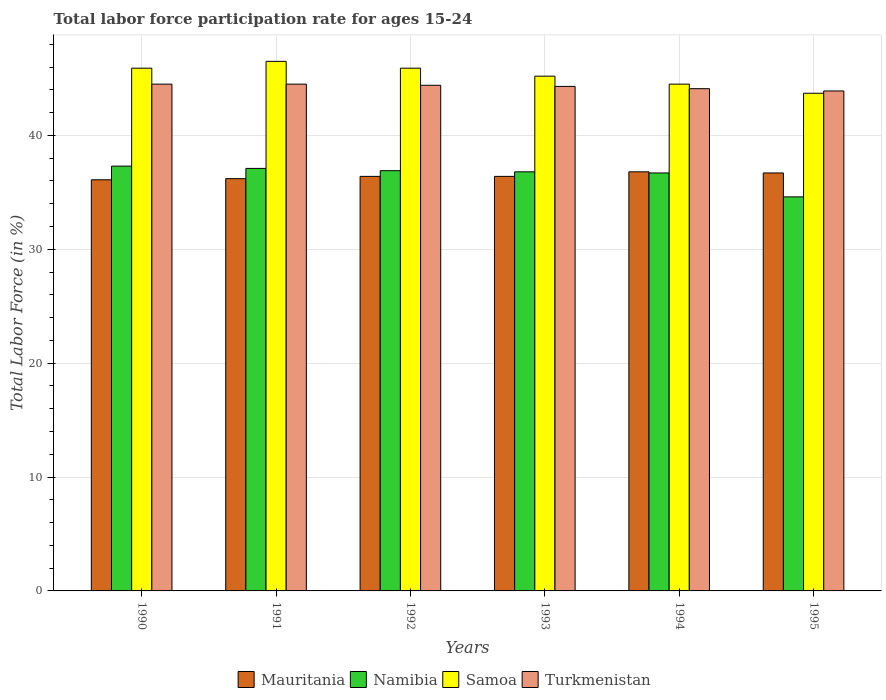How many different coloured bars are there?
Ensure brevity in your answer.  4. Are the number of bars per tick equal to the number of legend labels?
Offer a terse response. Yes. Are the number of bars on each tick of the X-axis equal?
Offer a very short reply. Yes. How many bars are there on the 5th tick from the left?
Keep it short and to the point. 4. What is the label of the 3rd group of bars from the left?
Your response must be concise. 1992. What is the labor force participation rate in Turkmenistan in 1991?
Provide a short and direct response. 44.5. Across all years, what is the maximum labor force participation rate in Samoa?
Your answer should be very brief. 46.5. Across all years, what is the minimum labor force participation rate in Turkmenistan?
Your answer should be compact. 43.9. In which year was the labor force participation rate in Namibia maximum?
Offer a very short reply. 1990. What is the total labor force participation rate in Namibia in the graph?
Ensure brevity in your answer.  219.4. What is the difference between the labor force participation rate in Namibia in 1991 and that in 1992?
Provide a succinct answer. 0.2. What is the difference between the labor force participation rate in Mauritania in 1992 and the labor force participation rate in Samoa in 1995?
Ensure brevity in your answer.  -7.3. What is the average labor force participation rate in Mauritania per year?
Give a very brief answer. 36.43. What is the ratio of the labor force participation rate in Namibia in 1991 to that in 1993?
Ensure brevity in your answer.  1.01. What is the difference between the highest and the second highest labor force participation rate in Samoa?
Provide a succinct answer. 0.6. What is the difference between the highest and the lowest labor force participation rate in Turkmenistan?
Provide a short and direct response. 0.6. Is it the case that in every year, the sum of the labor force participation rate in Samoa and labor force participation rate in Turkmenistan is greater than the sum of labor force participation rate in Mauritania and labor force participation rate in Namibia?
Offer a terse response. Yes. What does the 4th bar from the left in 1995 represents?
Your answer should be compact. Turkmenistan. What does the 4th bar from the right in 1994 represents?
Ensure brevity in your answer.  Mauritania. Are all the bars in the graph horizontal?
Ensure brevity in your answer.  No. Where does the legend appear in the graph?
Make the answer very short. Bottom center. What is the title of the graph?
Your response must be concise. Total labor force participation rate for ages 15-24. What is the label or title of the X-axis?
Offer a very short reply. Years. What is the label or title of the Y-axis?
Offer a very short reply. Total Labor Force (in %). What is the Total Labor Force (in %) in Mauritania in 1990?
Offer a very short reply. 36.1. What is the Total Labor Force (in %) of Namibia in 1990?
Keep it short and to the point. 37.3. What is the Total Labor Force (in %) of Samoa in 1990?
Your response must be concise. 45.9. What is the Total Labor Force (in %) in Turkmenistan in 1990?
Give a very brief answer. 44.5. What is the Total Labor Force (in %) of Mauritania in 1991?
Offer a terse response. 36.2. What is the Total Labor Force (in %) in Namibia in 1991?
Offer a very short reply. 37.1. What is the Total Labor Force (in %) of Samoa in 1991?
Ensure brevity in your answer.  46.5. What is the Total Labor Force (in %) in Turkmenistan in 1991?
Provide a succinct answer. 44.5. What is the Total Labor Force (in %) in Mauritania in 1992?
Your answer should be compact. 36.4. What is the Total Labor Force (in %) of Namibia in 1992?
Make the answer very short. 36.9. What is the Total Labor Force (in %) of Samoa in 1992?
Your response must be concise. 45.9. What is the Total Labor Force (in %) of Turkmenistan in 1992?
Offer a very short reply. 44.4. What is the Total Labor Force (in %) in Mauritania in 1993?
Offer a terse response. 36.4. What is the Total Labor Force (in %) of Namibia in 1993?
Provide a short and direct response. 36.8. What is the Total Labor Force (in %) in Samoa in 1993?
Offer a very short reply. 45.2. What is the Total Labor Force (in %) of Turkmenistan in 1993?
Provide a short and direct response. 44.3. What is the Total Labor Force (in %) of Mauritania in 1994?
Keep it short and to the point. 36.8. What is the Total Labor Force (in %) of Namibia in 1994?
Offer a terse response. 36.7. What is the Total Labor Force (in %) in Samoa in 1994?
Your answer should be compact. 44.5. What is the Total Labor Force (in %) of Turkmenistan in 1994?
Your response must be concise. 44.1. What is the Total Labor Force (in %) of Mauritania in 1995?
Offer a very short reply. 36.7. What is the Total Labor Force (in %) in Namibia in 1995?
Ensure brevity in your answer.  34.6. What is the Total Labor Force (in %) in Samoa in 1995?
Your answer should be very brief. 43.7. What is the Total Labor Force (in %) in Turkmenistan in 1995?
Offer a terse response. 43.9. Across all years, what is the maximum Total Labor Force (in %) of Mauritania?
Provide a succinct answer. 36.8. Across all years, what is the maximum Total Labor Force (in %) of Namibia?
Your answer should be very brief. 37.3. Across all years, what is the maximum Total Labor Force (in %) in Samoa?
Your answer should be very brief. 46.5. Across all years, what is the maximum Total Labor Force (in %) of Turkmenistan?
Your answer should be compact. 44.5. Across all years, what is the minimum Total Labor Force (in %) in Mauritania?
Keep it short and to the point. 36.1. Across all years, what is the minimum Total Labor Force (in %) of Namibia?
Your answer should be compact. 34.6. Across all years, what is the minimum Total Labor Force (in %) of Samoa?
Your answer should be very brief. 43.7. Across all years, what is the minimum Total Labor Force (in %) in Turkmenistan?
Provide a short and direct response. 43.9. What is the total Total Labor Force (in %) in Mauritania in the graph?
Keep it short and to the point. 218.6. What is the total Total Labor Force (in %) in Namibia in the graph?
Offer a terse response. 219.4. What is the total Total Labor Force (in %) of Samoa in the graph?
Your answer should be compact. 271.7. What is the total Total Labor Force (in %) in Turkmenistan in the graph?
Provide a short and direct response. 265.7. What is the difference between the Total Labor Force (in %) of Namibia in 1990 and that in 1991?
Offer a very short reply. 0.2. What is the difference between the Total Labor Force (in %) of Samoa in 1990 and that in 1992?
Make the answer very short. 0. What is the difference between the Total Labor Force (in %) in Mauritania in 1990 and that in 1993?
Keep it short and to the point. -0.3. What is the difference between the Total Labor Force (in %) of Samoa in 1990 and that in 1993?
Your answer should be very brief. 0.7. What is the difference between the Total Labor Force (in %) of Turkmenistan in 1990 and that in 1993?
Ensure brevity in your answer.  0.2. What is the difference between the Total Labor Force (in %) in Namibia in 1990 and that in 1994?
Give a very brief answer. 0.6. What is the difference between the Total Labor Force (in %) of Turkmenistan in 1990 and that in 1994?
Offer a very short reply. 0.4. What is the difference between the Total Labor Force (in %) in Turkmenistan in 1990 and that in 1995?
Provide a succinct answer. 0.6. What is the difference between the Total Labor Force (in %) of Mauritania in 1991 and that in 1992?
Make the answer very short. -0.2. What is the difference between the Total Labor Force (in %) of Namibia in 1991 and that in 1992?
Provide a short and direct response. 0.2. What is the difference between the Total Labor Force (in %) of Samoa in 1991 and that in 1992?
Offer a very short reply. 0.6. What is the difference between the Total Labor Force (in %) of Turkmenistan in 1991 and that in 1992?
Give a very brief answer. 0.1. What is the difference between the Total Labor Force (in %) of Namibia in 1991 and that in 1993?
Offer a very short reply. 0.3. What is the difference between the Total Labor Force (in %) of Samoa in 1991 and that in 1993?
Ensure brevity in your answer.  1.3. What is the difference between the Total Labor Force (in %) in Mauritania in 1991 and that in 1994?
Provide a succinct answer. -0.6. What is the difference between the Total Labor Force (in %) of Namibia in 1991 and that in 1994?
Your response must be concise. 0.4. What is the difference between the Total Labor Force (in %) of Samoa in 1991 and that in 1994?
Make the answer very short. 2. What is the difference between the Total Labor Force (in %) in Mauritania in 1991 and that in 1995?
Your answer should be compact. -0.5. What is the difference between the Total Labor Force (in %) of Turkmenistan in 1991 and that in 1995?
Provide a succinct answer. 0.6. What is the difference between the Total Labor Force (in %) of Mauritania in 1992 and that in 1993?
Your answer should be very brief. 0. What is the difference between the Total Labor Force (in %) in Namibia in 1992 and that in 1994?
Your response must be concise. 0.2. What is the difference between the Total Labor Force (in %) in Samoa in 1992 and that in 1994?
Make the answer very short. 1.4. What is the difference between the Total Labor Force (in %) in Turkmenistan in 1992 and that in 1994?
Your response must be concise. 0.3. What is the difference between the Total Labor Force (in %) in Mauritania in 1992 and that in 1995?
Make the answer very short. -0.3. What is the difference between the Total Labor Force (in %) in Turkmenistan in 1992 and that in 1995?
Offer a terse response. 0.5. What is the difference between the Total Labor Force (in %) of Namibia in 1993 and that in 1994?
Ensure brevity in your answer.  0.1. What is the difference between the Total Labor Force (in %) of Turkmenistan in 1993 and that in 1994?
Ensure brevity in your answer.  0.2. What is the difference between the Total Labor Force (in %) of Mauritania in 1993 and that in 1995?
Ensure brevity in your answer.  -0.3. What is the difference between the Total Labor Force (in %) in Samoa in 1993 and that in 1995?
Offer a terse response. 1.5. What is the difference between the Total Labor Force (in %) of Samoa in 1994 and that in 1995?
Ensure brevity in your answer.  0.8. What is the difference between the Total Labor Force (in %) of Turkmenistan in 1994 and that in 1995?
Ensure brevity in your answer.  0.2. What is the difference between the Total Labor Force (in %) in Mauritania in 1990 and the Total Labor Force (in %) in Turkmenistan in 1991?
Provide a short and direct response. -8.4. What is the difference between the Total Labor Force (in %) in Mauritania in 1990 and the Total Labor Force (in %) in Namibia in 1992?
Make the answer very short. -0.8. What is the difference between the Total Labor Force (in %) in Mauritania in 1990 and the Total Labor Force (in %) in Samoa in 1992?
Provide a succinct answer. -9.8. What is the difference between the Total Labor Force (in %) in Mauritania in 1990 and the Total Labor Force (in %) in Turkmenistan in 1992?
Provide a succinct answer. -8.3. What is the difference between the Total Labor Force (in %) in Namibia in 1990 and the Total Labor Force (in %) in Samoa in 1992?
Offer a terse response. -8.6. What is the difference between the Total Labor Force (in %) in Samoa in 1990 and the Total Labor Force (in %) in Turkmenistan in 1992?
Offer a terse response. 1.5. What is the difference between the Total Labor Force (in %) of Mauritania in 1990 and the Total Labor Force (in %) of Namibia in 1993?
Provide a succinct answer. -0.7. What is the difference between the Total Labor Force (in %) of Mauritania in 1990 and the Total Labor Force (in %) of Samoa in 1993?
Provide a succinct answer. -9.1. What is the difference between the Total Labor Force (in %) in Namibia in 1990 and the Total Labor Force (in %) in Samoa in 1993?
Your answer should be very brief. -7.9. What is the difference between the Total Labor Force (in %) in Samoa in 1990 and the Total Labor Force (in %) in Turkmenistan in 1993?
Provide a short and direct response. 1.6. What is the difference between the Total Labor Force (in %) of Mauritania in 1990 and the Total Labor Force (in %) of Namibia in 1994?
Give a very brief answer. -0.6. What is the difference between the Total Labor Force (in %) of Namibia in 1990 and the Total Labor Force (in %) of Samoa in 1994?
Your answer should be very brief. -7.2. What is the difference between the Total Labor Force (in %) of Namibia in 1990 and the Total Labor Force (in %) of Turkmenistan in 1994?
Give a very brief answer. -6.8. What is the difference between the Total Labor Force (in %) in Mauritania in 1990 and the Total Labor Force (in %) in Namibia in 1995?
Your answer should be very brief. 1.5. What is the difference between the Total Labor Force (in %) in Namibia in 1990 and the Total Labor Force (in %) in Samoa in 1995?
Provide a short and direct response. -6.4. What is the difference between the Total Labor Force (in %) in Samoa in 1990 and the Total Labor Force (in %) in Turkmenistan in 1995?
Your answer should be compact. 2. What is the difference between the Total Labor Force (in %) of Mauritania in 1991 and the Total Labor Force (in %) of Namibia in 1992?
Provide a short and direct response. -0.7. What is the difference between the Total Labor Force (in %) of Mauritania in 1991 and the Total Labor Force (in %) of Turkmenistan in 1992?
Provide a short and direct response. -8.2. What is the difference between the Total Labor Force (in %) in Namibia in 1991 and the Total Labor Force (in %) in Turkmenistan in 1992?
Provide a short and direct response. -7.3. What is the difference between the Total Labor Force (in %) in Mauritania in 1991 and the Total Labor Force (in %) in Samoa in 1993?
Your answer should be compact. -9. What is the difference between the Total Labor Force (in %) of Namibia in 1991 and the Total Labor Force (in %) of Samoa in 1994?
Your response must be concise. -7.4. What is the difference between the Total Labor Force (in %) in Namibia in 1991 and the Total Labor Force (in %) in Turkmenistan in 1994?
Keep it short and to the point. -7. What is the difference between the Total Labor Force (in %) of Mauritania in 1991 and the Total Labor Force (in %) of Samoa in 1995?
Give a very brief answer. -7.5. What is the difference between the Total Labor Force (in %) in Namibia in 1991 and the Total Labor Force (in %) in Samoa in 1995?
Your answer should be compact. -6.6. What is the difference between the Total Labor Force (in %) in Samoa in 1991 and the Total Labor Force (in %) in Turkmenistan in 1995?
Provide a short and direct response. 2.6. What is the difference between the Total Labor Force (in %) in Mauritania in 1992 and the Total Labor Force (in %) in Namibia in 1993?
Provide a succinct answer. -0.4. What is the difference between the Total Labor Force (in %) in Mauritania in 1992 and the Total Labor Force (in %) in Samoa in 1993?
Your response must be concise. -8.8. What is the difference between the Total Labor Force (in %) of Mauritania in 1992 and the Total Labor Force (in %) of Turkmenistan in 1993?
Offer a very short reply. -7.9. What is the difference between the Total Labor Force (in %) in Namibia in 1992 and the Total Labor Force (in %) in Turkmenistan in 1993?
Offer a terse response. -7.4. What is the difference between the Total Labor Force (in %) in Samoa in 1992 and the Total Labor Force (in %) in Turkmenistan in 1993?
Provide a short and direct response. 1.6. What is the difference between the Total Labor Force (in %) in Mauritania in 1992 and the Total Labor Force (in %) in Namibia in 1994?
Keep it short and to the point. -0.3. What is the difference between the Total Labor Force (in %) in Mauritania in 1992 and the Total Labor Force (in %) in Samoa in 1994?
Provide a succinct answer. -8.1. What is the difference between the Total Labor Force (in %) in Namibia in 1992 and the Total Labor Force (in %) in Turkmenistan in 1994?
Your response must be concise. -7.2. What is the difference between the Total Labor Force (in %) of Mauritania in 1992 and the Total Labor Force (in %) of Namibia in 1995?
Keep it short and to the point. 1.8. What is the difference between the Total Labor Force (in %) in Mauritania in 1992 and the Total Labor Force (in %) in Turkmenistan in 1995?
Offer a terse response. -7.5. What is the difference between the Total Labor Force (in %) of Namibia in 1992 and the Total Labor Force (in %) of Turkmenistan in 1995?
Offer a terse response. -7. What is the difference between the Total Labor Force (in %) of Samoa in 1992 and the Total Labor Force (in %) of Turkmenistan in 1995?
Keep it short and to the point. 2. What is the difference between the Total Labor Force (in %) in Mauritania in 1993 and the Total Labor Force (in %) in Namibia in 1994?
Keep it short and to the point. -0.3. What is the difference between the Total Labor Force (in %) of Namibia in 1993 and the Total Labor Force (in %) of Turkmenistan in 1994?
Your answer should be very brief. -7.3. What is the difference between the Total Labor Force (in %) of Samoa in 1993 and the Total Labor Force (in %) of Turkmenistan in 1994?
Offer a very short reply. 1.1. What is the difference between the Total Labor Force (in %) in Mauritania in 1993 and the Total Labor Force (in %) in Namibia in 1995?
Provide a short and direct response. 1.8. What is the difference between the Total Labor Force (in %) of Mauritania in 1993 and the Total Labor Force (in %) of Samoa in 1995?
Keep it short and to the point. -7.3. What is the difference between the Total Labor Force (in %) of Mauritania in 1994 and the Total Labor Force (in %) of Namibia in 1995?
Your answer should be compact. 2.2. What is the difference between the Total Labor Force (in %) of Namibia in 1994 and the Total Labor Force (in %) of Samoa in 1995?
Your response must be concise. -7. What is the average Total Labor Force (in %) in Mauritania per year?
Offer a terse response. 36.43. What is the average Total Labor Force (in %) of Namibia per year?
Provide a succinct answer. 36.57. What is the average Total Labor Force (in %) of Samoa per year?
Offer a very short reply. 45.28. What is the average Total Labor Force (in %) in Turkmenistan per year?
Provide a succinct answer. 44.28. In the year 1990, what is the difference between the Total Labor Force (in %) of Mauritania and Total Labor Force (in %) of Turkmenistan?
Give a very brief answer. -8.4. In the year 1990, what is the difference between the Total Labor Force (in %) in Namibia and Total Labor Force (in %) in Turkmenistan?
Your response must be concise. -7.2. In the year 1990, what is the difference between the Total Labor Force (in %) of Samoa and Total Labor Force (in %) of Turkmenistan?
Give a very brief answer. 1.4. In the year 1991, what is the difference between the Total Labor Force (in %) in Mauritania and Total Labor Force (in %) in Namibia?
Ensure brevity in your answer.  -0.9. In the year 1991, what is the difference between the Total Labor Force (in %) of Mauritania and Total Labor Force (in %) of Samoa?
Provide a succinct answer. -10.3. In the year 1991, what is the difference between the Total Labor Force (in %) of Mauritania and Total Labor Force (in %) of Turkmenistan?
Provide a succinct answer. -8.3. In the year 1991, what is the difference between the Total Labor Force (in %) of Namibia and Total Labor Force (in %) of Turkmenistan?
Your answer should be compact. -7.4. In the year 1992, what is the difference between the Total Labor Force (in %) of Mauritania and Total Labor Force (in %) of Samoa?
Offer a very short reply. -9.5. In the year 1992, what is the difference between the Total Labor Force (in %) of Mauritania and Total Labor Force (in %) of Turkmenistan?
Provide a short and direct response. -8. In the year 1992, what is the difference between the Total Labor Force (in %) of Namibia and Total Labor Force (in %) of Samoa?
Your response must be concise. -9. In the year 1992, what is the difference between the Total Labor Force (in %) in Samoa and Total Labor Force (in %) in Turkmenistan?
Your answer should be compact. 1.5. In the year 1993, what is the difference between the Total Labor Force (in %) of Mauritania and Total Labor Force (in %) of Turkmenistan?
Keep it short and to the point. -7.9. In the year 1993, what is the difference between the Total Labor Force (in %) of Namibia and Total Labor Force (in %) of Samoa?
Ensure brevity in your answer.  -8.4. In the year 1993, what is the difference between the Total Labor Force (in %) of Namibia and Total Labor Force (in %) of Turkmenistan?
Offer a very short reply. -7.5. In the year 1994, what is the difference between the Total Labor Force (in %) in Mauritania and Total Labor Force (in %) in Namibia?
Your answer should be compact. 0.1. In the year 1994, what is the difference between the Total Labor Force (in %) in Mauritania and Total Labor Force (in %) in Turkmenistan?
Provide a short and direct response. -7.3. In the year 1994, what is the difference between the Total Labor Force (in %) of Namibia and Total Labor Force (in %) of Samoa?
Make the answer very short. -7.8. In the year 1995, what is the difference between the Total Labor Force (in %) of Mauritania and Total Labor Force (in %) of Namibia?
Ensure brevity in your answer.  2.1. In the year 1995, what is the difference between the Total Labor Force (in %) in Namibia and Total Labor Force (in %) in Turkmenistan?
Provide a short and direct response. -9.3. What is the ratio of the Total Labor Force (in %) in Mauritania in 1990 to that in 1991?
Keep it short and to the point. 1. What is the ratio of the Total Labor Force (in %) of Namibia in 1990 to that in 1991?
Your response must be concise. 1.01. What is the ratio of the Total Labor Force (in %) in Samoa in 1990 to that in 1991?
Make the answer very short. 0.99. What is the ratio of the Total Labor Force (in %) in Namibia in 1990 to that in 1992?
Your response must be concise. 1.01. What is the ratio of the Total Labor Force (in %) of Namibia in 1990 to that in 1993?
Your answer should be very brief. 1.01. What is the ratio of the Total Labor Force (in %) of Samoa in 1990 to that in 1993?
Provide a succinct answer. 1.02. What is the ratio of the Total Labor Force (in %) of Namibia in 1990 to that in 1994?
Provide a succinct answer. 1.02. What is the ratio of the Total Labor Force (in %) of Samoa in 1990 to that in 1994?
Offer a terse response. 1.03. What is the ratio of the Total Labor Force (in %) in Turkmenistan in 1990 to that in 1994?
Your answer should be compact. 1.01. What is the ratio of the Total Labor Force (in %) in Mauritania in 1990 to that in 1995?
Your response must be concise. 0.98. What is the ratio of the Total Labor Force (in %) of Namibia in 1990 to that in 1995?
Provide a succinct answer. 1.08. What is the ratio of the Total Labor Force (in %) of Samoa in 1990 to that in 1995?
Make the answer very short. 1.05. What is the ratio of the Total Labor Force (in %) in Turkmenistan in 1990 to that in 1995?
Your response must be concise. 1.01. What is the ratio of the Total Labor Force (in %) of Mauritania in 1991 to that in 1992?
Your response must be concise. 0.99. What is the ratio of the Total Labor Force (in %) in Namibia in 1991 to that in 1992?
Make the answer very short. 1.01. What is the ratio of the Total Labor Force (in %) in Samoa in 1991 to that in 1992?
Your answer should be compact. 1.01. What is the ratio of the Total Labor Force (in %) in Namibia in 1991 to that in 1993?
Provide a short and direct response. 1.01. What is the ratio of the Total Labor Force (in %) in Samoa in 1991 to that in 1993?
Offer a very short reply. 1.03. What is the ratio of the Total Labor Force (in %) in Mauritania in 1991 to that in 1994?
Ensure brevity in your answer.  0.98. What is the ratio of the Total Labor Force (in %) of Namibia in 1991 to that in 1994?
Keep it short and to the point. 1.01. What is the ratio of the Total Labor Force (in %) in Samoa in 1991 to that in 1994?
Ensure brevity in your answer.  1.04. What is the ratio of the Total Labor Force (in %) of Turkmenistan in 1991 to that in 1994?
Give a very brief answer. 1.01. What is the ratio of the Total Labor Force (in %) in Mauritania in 1991 to that in 1995?
Offer a very short reply. 0.99. What is the ratio of the Total Labor Force (in %) in Namibia in 1991 to that in 1995?
Make the answer very short. 1.07. What is the ratio of the Total Labor Force (in %) in Samoa in 1991 to that in 1995?
Give a very brief answer. 1.06. What is the ratio of the Total Labor Force (in %) of Turkmenistan in 1991 to that in 1995?
Offer a terse response. 1.01. What is the ratio of the Total Labor Force (in %) in Mauritania in 1992 to that in 1993?
Your answer should be compact. 1. What is the ratio of the Total Labor Force (in %) of Namibia in 1992 to that in 1993?
Provide a succinct answer. 1. What is the ratio of the Total Labor Force (in %) of Samoa in 1992 to that in 1993?
Offer a very short reply. 1.02. What is the ratio of the Total Labor Force (in %) in Mauritania in 1992 to that in 1994?
Keep it short and to the point. 0.99. What is the ratio of the Total Labor Force (in %) of Namibia in 1992 to that in 1994?
Your answer should be very brief. 1.01. What is the ratio of the Total Labor Force (in %) in Samoa in 1992 to that in 1994?
Provide a short and direct response. 1.03. What is the ratio of the Total Labor Force (in %) in Turkmenistan in 1992 to that in 1994?
Your response must be concise. 1.01. What is the ratio of the Total Labor Force (in %) of Mauritania in 1992 to that in 1995?
Your answer should be compact. 0.99. What is the ratio of the Total Labor Force (in %) in Namibia in 1992 to that in 1995?
Offer a very short reply. 1.07. What is the ratio of the Total Labor Force (in %) of Samoa in 1992 to that in 1995?
Ensure brevity in your answer.  1.05. What is the ratio of the Total Labor Force (in %) in Turkmenistan in 1992 to that in 1995?
Keep it short and to the point. 1.01. What is the ratio of the Total Labor Force (in %) of Mauritania in 1993 to that in 1994?
Your response must be concise. 0.99. What is the ratio of the Total Labor Force (in %) in Samoa in 1993 to that in 1994?
Your answer should be compact. 1.02. What is the ratio of the Total Labor Force (in %) of Namibia in 1993 to that in 1995?
Provide a succinct answer. 1.06. What is the ratio of the Total Labor Force (in %) of Samoa in 1993 to that in 1995?
Give a very brief answer. 1.03. What is the ratio of the Total Labor Force (in %) of Turkmenistan in 1993 to that in 1995?
Offer a very short reply. 1.01. What is the ratio of the Total Labor Force (in %) of Namibia in 1994 to that in 1995?
Your response must be concise. 1.06. What is the ratio of the Total Labor Force (in %) in Samoa in 1994 to that in 1995?
Your response must be concise. 1.02. What is the ratio of the Total Labor Force (in %) of Turkmenistan in 1994 to that in 1995?
Keep it short and to the point. 1. What is the difference between the highest and the second highest Total Labor Force (in %) in Mauritania?
Offer a terse response. 0.1. What is the difference between the highest and the second highest Total Labor Force (in %) of Namibia?
Give a very brief answer. 0.2. What is the difference between the highest and the second highest Total Labor Force (in %) of Samoa?
Provide a succinct answer. 0.6. What is the difference between the highest and the second highest Total Labor Force (in %) of Turkmenistan?
Offer a terse response. 0. What is the difference between the highest and the lowest Total Labor Force (in %) in Mauritania?
Your answer should be very brief. 0.7. What is the difference between the highest and the lowest Total Labor Force (in %) of Namibia?
Give a very brief answer. 2.7. What is the difference between the highest and the lowest Total Labor Force (in %) of Samoa?
Offer a very short reply. 2.8. 